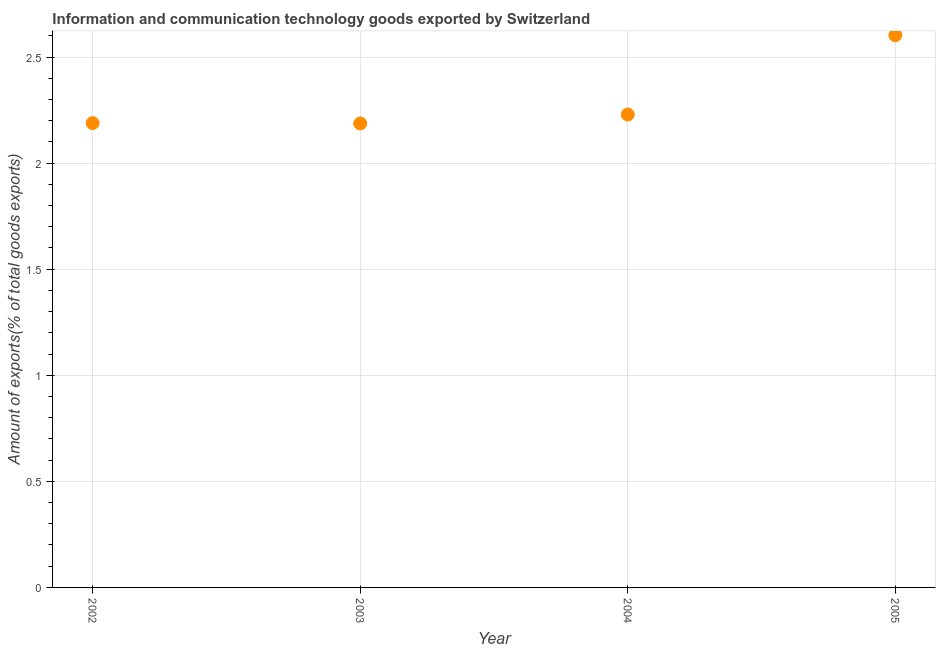What is the amount of ict goods exports in 2003?
Your response must be concise. 2.19. Across all years, what is the maximum amount of ict goods exports?
Offer a very short reply. 2.6. Across all years, what is the minimum amount of ict goods exports?
Offer a terse response. 2.19. In which year was the amount of ict goods exports maximum?
Give a very brief answer. 2005. In which year was the amount of ict goods exports minimum?
Your answer should be compact. 2003. What is the sum of the amount of ict goods exports?
Give a very brief answer. 9.21. What is the difference between the amount of ict goods exports in 2003 and 2004?
Your answer should be compact. -0.04. What is the average amount of ict goods exports per year?
Your answer should be compact. 2.3. What is the median amount of ict goods exports?
Provide a short and direct response. 2.21. In how many years, is the amount of ict goods exports greater than 0.2 %?
Give a very brief answer. 4. Do a majority of the years between 2003 and 2002 (inclusive) have amount of ict goods exports greater than 1.5 %?
Keep it short and to the point. No. What is the ratio of the amount of ict goods exports in 2002 to that in 2005?
Give a very brief answer. 0.84. What is the difference between the highest and the second highest amount of ict goods exports?
Keep it short and to the point. 0.37. Is the sum of the amount of ict goods exports in 2002 and 2004 greater than the maximum amount of ict goods exports across all years?
Provide a succinct answer. Yes. What is the difference between the highest and the lowest amount of ict goods exports?
Keep it short and to the point. 0.42. What is the difference between two consecutive major ticks on the Y-axis?
Ensure brevity in your answer.  0.5. Does the graph contain any zero values?
Your answer should be very brief. No. Does the graph contain grids?
Provide a short and direct response. Yes. What is the title of the graph?
Provide a succinct answer. Information and communication technology goods exported by Switzerland. What is the label or title of the Y-axis?
Provide a short and direct response. Amount of exports(% of total goods exports). What is the Amount of exports(% of total goods exports) in 2002?
Keep it short and to the point. 2.19. What is the Amount of exports(% of total goods exports) in 2003?
Offer a very short reply. 2.19. What is the Amount of exports(% of total goods exports) in 2004?
Provide a succinct answer. 2.23. What is the Amount of exports(% of total goods exports) in 2005?
Provide a short and direct response. 2.6. What is the difference between the Amount of exports(% of total goods exports) in 2002 and 2003?
Offer a very short reply. 0. What is the difference between the Amount of exports(% of total goods exports) in 2002 and 2004?
Your answer should be very brief. -0.04. What is the difference between the Amount of exports(% of total goods exports) in 2002 and 2005?
Give a very brief answer. -0.41. What is the difference between the Amount of exports(% of total goods exports) in 2003 and 2004?
Your answer should be compact. -0.04. What is the difference between the Amount of exports(% of total goods exports) in 2003 and 2005?
Your answer should be very brief. -0.42. What is the difference between the Amount of exports(% of total goods exports) in 2004 and 2005?
Keep it short and to the point. -0.37. What is the ratio of the Amount of exports(% of total goods exports) in 2002 to that in 2005?
Your response must be concise. 0.84. What is the ratio of the Amount of exports(% of total goods exports) in 2003 to that in 2004?
Keep it short and to the point. 0.98. What is the ratio of the Amount of exports(% of total goods exports) in 2003 to that in 2005?
Ensure brevity in your answer.  0.84. What is the ratio of the Amount of exports(% of total goods exports) in 2004 to that in 2005?
Your answer should be very brief. 0.86. 